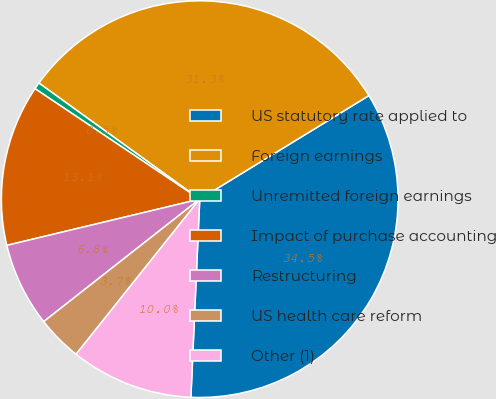Convert chart. <chart><loc_0><loc_0><loc_500><loc_500><pie_chart><fcel>US statutory rate applied to<fcel>Foreign earnings<fcel>Unremitted foreign earnings<fcel>Impact of purchase accounting<fcel>Restructuring<fcel>US health care reform<fcel>Other (1)<nl><fcel>34.46%<fcel>31.31%<fcel>0.55%<fcel>13.15%<fcel>6.85%<fcel>3.7%<fcel>10.0%<nl></chart> 